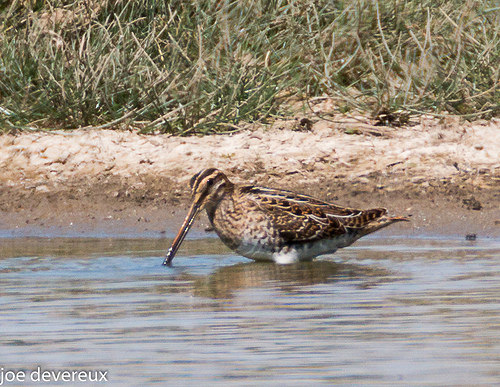<image>
Can you confirm if the bird is on the ground? No. The bird is not positioned on the ground. They may be near each other, but the bird is not supported by or resting on top of the ground. 